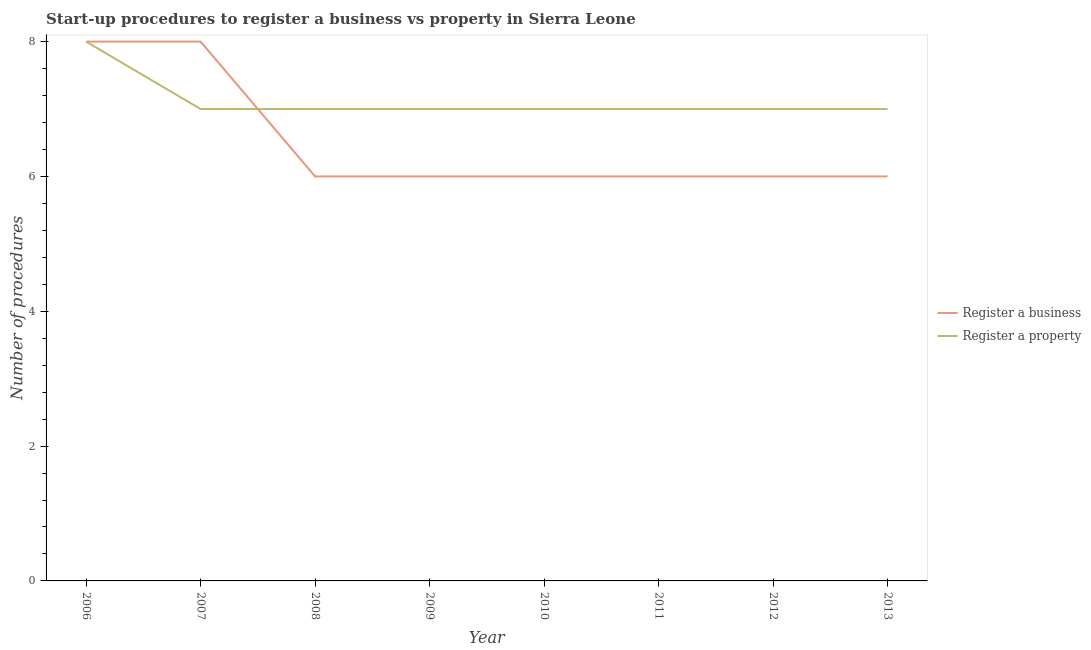How many different coloured lines are there?
Your answer should be very brief. 2. What is the number of procedures to register a property in 2013?
Keep it short and to the point. 7. Across all years, what is the maximum number of procedures to register a business?
Your answer should be compact. 8. Across all years, what is the minimum number of procedures to register a business?
Your answer should be very brief. 6. In which year was the number of procedures to register a property maximum?
Provide a short and direct response. 2006. What is the total number of procedures to register a business in the graph?
Provide a short and direct response. 52. What is the difference between the number of procedures to register a property in 2006 and that in 2010?
Your answer should be compact. 1. What is the difference between the number of procedures to register a property in 2009 and the number of procedures to register a business in 2012?
Your response must be concise. 1. What is the average number of procedures to register a business per year?
Ensure brevity in your answer.  6.5. In the year 2008, what is the difference between the number of procedures to register a business and number of procedures to register a property?
Make the answer very short. -1. In how many years, is the number of procedures to register a business greater than 5.2?
Provide a short and direct response. 8. What is the ratio of the number of procedures to register a property in 2006 to that in 2013?
Provide a succinct answer. 1.14. What is the difference between the highest and the second highest number of procedures to register a property?
Your answer should be compact. 1. What is the difference between the highest and the lowest number of procedures to register a business?
Offer a terse response. 2. Does the number of procedures to register a business monotonically increase over the years?
Make the answer very short. No. Is the number of procedures to register a property strictly greater than the number of procedures to register a business over the years?
Give a very brief answer. No. Is the number of procedures to register a property strictly less than the number of procedures to register a business over the years?
Provide a succinct answer. No. How many years are there in the graph?
Offer a terse response. 8. Does the graph contain grids?
Provide a short and direct response. No. How many legend labels are there?
Your answer should be compact. 2. What is the title of the graph?
Your answer should be very brief. Start-up procedures to register a business vs property in Sierra Leone. Does "Under-5(female)" appear as one of the legend labels in the graph?
Provide a succinct answer. No. What is the label or title of the X-axis?
Keep it short and to the point. Year. What is the label or title of the Y-axis?
Offer a very short reply. Number of procedures. What is the Number of procedures of Register a property in 2006?
Your answer should be very brief. 8. What is the Number of procedures in Register a business in 2008?
Your answer should be very brief. 6. What is the Number of procedures of Register a business in 2009?
Offer a very short reply. 6. What is the Number of procedures of Register a property in 2009?
Give a very brief answer. 7. What is the Number of procedures of Register a business in 2010?
Ensure brevity in your answer.  6. What is the Number of procedures in Register a property in 2010?
Offer a very short reply. 7. What is the Number of procedures of Register a business in 2012?
Provide a succinct answer. 6. What is the Number of procedures in Register a business in 2013?
Provide a short and direct response. 6. Across all years, what is the maximum Number of procedures in Register a business?
Provide a short and direct response. 8. Across all years, what is the maximum Number of procedures of Register a property?
Your response must be concise. 8. What is the difference between the Number of procedures in Register a business in 2006 and that in 2007?
Keep it short and to the point. 0. What is the difference between the Number of procedures of Register a business in 2006 and that in 2008?
Your answer should be compact. 2. What is the difference between the Number of procedures in Register a property in 2006 and that in 2008?
Provide a short and direct response. 1. What is the difference between the Number of procedures of Register a property in 2006 and that in 2009?
Offer a terse response. 1. What is the difference between the Number of procedures in Register a business in 2006 and that in 2010?
Keep it short and to the point. 2. What is the difference between the Number of procedures of Register a property in 2006 and that in 2010?
Offer a very short reply. 1. What is the difference between the Number of procedures of Register a business in 2006 and that in 2012?
Give a very brief answer. 2. What is the difference between the Number of procedures of Register a business in 2007 and that in 2008?
Provide a succinct answer. 2. What is the difference between the Number of procedures in Register a property in 2007 and that in 2010?
Offer a terse response. 0. What is the difference between the Number of procedures in Register a business in 2007 and that in 2011?
Give a very brief answer. 2. What is the difference between the Number of procedures of Register a business in 2007 and that in 2012?
Ensure brevity in your answer.  2. What is the difference between the Number of procedures of Register a property in 2007 and that in 2012?
Keep it short and to the point. 0. What is the difference between the Number of procedures in Register a business in 2007 and that in 2013?
Ensure brevity in your answer.  2. What is the difference between the Number of procedures of Register a property in 2007 and that in 2013?
Offer a very short reply. 0. What is the difference between the Number of procedures of Register a business in 2008 and that in 2009?
Your answer should be very brief. 0. What is the difference between the Number of procedures in Register a business in 2008 and that in 2010?
Make the answer very short. 0. What is the difference between the Number of procedures of Register a property in 2008 and that in 2010?
Make the answer very short. 0. What is the difference between the Number of procedures in Register a business in 2008 and that in 2011?
Offer a terse response. 0. What is the difference between the Number of procedures of Register a business in 2008 and that in 2013?
Ensure brevity in your answer.  0. What is the difference between the Number of procedures in Register a property in 2008 and that in 2013?
Your answer should be very brief. 0. What is the difference between the Number of procedures in Register a property in 2009 and that in 2010?
Your response must be concise. 0. What is the difference between the Number of procedures of Register a property in 2010 and that in 2011?
Provide a short and direct response. 0. What is the difference between the Number of procedures of Register a property in 2010 and that in 2012?
Your answer should be very brief. 0. What is the difference between the Number of procedures in Register a property in 2011 and that in 2012?
Make the answer very short. 0. What is the difference between the Number of procedures in Register a business in 2011 and that in 2013?
Keep it short and to the point. 0. What is the difference between the Number of procedures of Register a property in 2012 and that in 2013?
Offer a terse response. 0. What is the difference between the Number of procedures of Register a business in 2006 and the Number of procedures of Register a property in 2007?
Keep it short and to the point. 1. What is the difference between the Number of procedures in Register a business in 2006 and the Number of procedures in Register a property in 2008?
Make the answer very short. 1. What is the difference between the Number of procedures in Register a business in 2006 and the Number of procedures in Register a property in 2009?
Give a very brief answer. 1. What is the difference between the Number of procedures in Register a business in 2006 and the Number of procedures in Register a property in 2011?
Offer a terse response. 1. What is the difference between the Number of procedures of Register a business in 2006 and the Number of procedures of Register a property in 2012?
Provide a succinct answer. 1. What is the difference between the Number of procedures of Register a business in 2007 and the Number of procedures of Register a property in 2009?
Offer a very short reply. 1. What is the difference between the Number of procedures in Register a business in 2007 and the Number of procedures in Register a property in 2011?
Ensure brevity in your answer.  1. What is the difference between the Number of procedures in Register a business in 2007 and the Number of procedures in Register a property in 2013?
Provide a short and direct response. 1. What is the difference between the Number of procedures in Register a business in 2008 and the Number of procedures in Register a property in 2011?
Your response must be concise. -1. What is the difference between the Number of procedures of Register a business in 2009 and the Number of procedures of Register a property in 2011?
Your answer should be very brief. -1. What is the difference between the Number of procedures of Register a business in 2009 and the Number of procedures of Register a property in 2012?
Offer a very short reply. -1. What is the difference between the Number of procedures in Register a business in 2009 and the Number of procedures in Register a property in 2013?
Your response must be concise. -1. What is the difference between the Number of procedures in Register a business in 2010 and the Number of procedures in Register a property in 2012?
Ensure brevity in your answer.  -1. What is the difference between the Number of procedures in Register a business in 2011 and the Number of procedures in Register a property in 2013?
Keep it short and to the point. -1. What is the average Number of procedures of Register a property per year?
Your answer should be compact. 7.12. In the year 2007, what is the difference between the Number of procedures in Register a business and Number of procedures in Register a property?
Provide a succinct answer. 1. In the year 2008, what is the difference between the Number of procedures of Register a business and Number of procedures of Register a property?
Your answer should be compact. -1. In the year 2013, what is the difference between the Number of procedures of Register a business and Number of procedures of Register a property?
Your answer should be compact. -1. What is the ratio of the Number of procedures of Register a property in 2006 to that in 2007?
Offer a terse response. 1.14. What is the ratio of the Number of procedures in Register a business in 2006 to that in 2008?
Provide a short and direct response. 1.33. What is the ratio of the Number of procedures of Register a business in 2006 to that in 2009?
Your response must be concise. 1.33. What is the ratio of the Number of procedures in Register a business in 2006 to that in 2010?
Keep it short and to the point. 1.33. What is the ratio of the Number of procedures of Register a business in 2006 to that in 2011?
Your answer should be compact. 1.33. What is the ratio of the Number of procedures in Register a business in 2006 to that in 2012?
Keep it short and to the point. 1.33. What is the ratio of the Number of procedures in Register a business in 2006 to that in 2013?
Give a very brief answer. 1.33. What is the ratio of the Number of procedures in Register a property in 2006 to that in 2013?
Ensure brevity in your answer.  1.14. What is the ratio of the Number of procedures in Register a business in 2007 to that in 2008?
Keep it short and to the point. 1.33. What is the ratio of the Number of procedures of Register a business in 2007 to that in 2010?
Offer a very short reply. 1.33. What is the ratio of the Number of procedures in Register a property in 2007 to that in 2010?
Provide a short and direct response. 1. What is the ratio of the Number of procedures in Register a property in 2007 to that in 2011?
Make the answer very short. 1. What is the ratio of the Number of procedures in Register a business in 2007 to that in 2012?
Give a very brief answer. 1.33. What is the ratio of the Number of procedures in Register a business in 2007 to that in 2013?
Provide a succinct answer. 1.33. What is the ratio of the Number of procedures in Register a business in 2008 to that in 2011?
Offer a terse response. 1. What is the ratio of the Number of procedures of Register a property in 2008 to that in 2011?
Offer a terse response. 1. What is the ratio of the Number of procedures in Register a property in 2009 to that in 2010?
Ensure brevity in your answer.  1. What is the ratio of the Number of procedures of Register a business in 2009 to that in 2011?
Your answer should be compact. 1. What is the ratio of the Number of procedures of Register a business in 2009 to that in 2012?
Keep it short and to the point. 1. What is the ratio of the Number of procedures in Register a property in 2009 to that in 2012?
Offer a very short reply. 1. What is the ratio of the Number of procedures of Register a business in 2009 to that in 2013?
Make the answer very short. 1. What is the ratio of the Number of procedures of Register a property in 2009 to that in 2013?
Keep it short and to the point. 1. What is the ratio of the Number of procedures in Register a business in 2010 to that in 2011?
Your response must be concise. 1. What is the ratio of the Number of procedures in Register a property in 2010 to that in 2011?
Ensure brevity in your answer.  1. What is the ratio of the Number of procedures of Register a business in 2010 to that in 2013?
Offer a very short reply. 1. What is the ratio of the Number of procedures of Register a property in 2010 to that in 2013?
Provide a succinct answer. 1. What is the ratio of the Number of procedures of Register a property in 2011 to that in 2012?
Ensure brevity in your answer.  1. What is the ratio of the Number of procedures of Register a business in 2012 to that in 2013?
Offer a very short reply. 1. What is the difference between the highest and the second highest Number of procedures in Register a business?
Provide a short and direct response. 0. What is the difference between the highest and the second highest Number of procedures in Register a property?
Give a very brief answer. 1. 